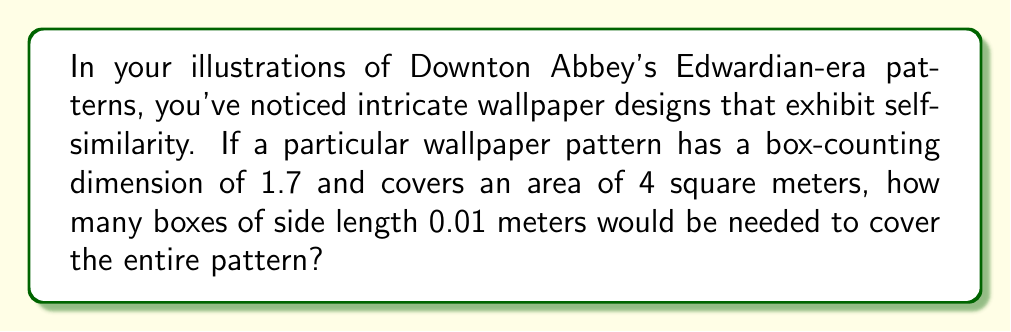Could you help me with this problem? To solve this problem, we'll use the concept of fractal dimension and the box-counting method:

1. The box-counting dimension (D) is given as 1.7.

2. The formula relating the number of boxes (N) to the box size (r) is:
   $$N(r) = c \cdot r^{-D}$$
   where c is a constant.

3. We're asked to find N when r = 0.01 meters.

4. To eliminate the constant c, we can use the total area information:
   Area = 4 m² = 40,000 cm²

5. If we consider boxes of side length 1 cm (0.01 m), we know:
   $$40000 = c \cdot 1^{-D}$$
   $$c = 40000$$

6. Now we can substitute this into our original equation:
   $$N(0.01) = 40000 \cdot 0.01^{-1.7}$$

7. Calculate:
   $$N(0.01) = 40000 \cdot 100^{1.7}$$
   $$N(0.01) = 40000 \cdot 10^{3.4}$$
   $$N(0.01) = 40000 \cdot 2511.88...$$
   $$N(0.01) \approx 100,475,200$$

Therefore, approximately 100,475,200 boxes of side length 0.01 meters would be needed to cover the entire pattern.
Answer: 100,475,200 boxes 